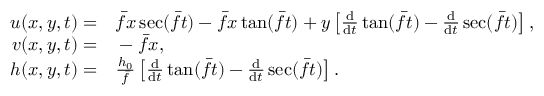Convert formula to latex. <formula><loc_0><loc_0><loc_500><loc_500>\begin{array} { r l } { u ( x , y , t ) = } & \bar { f } x \sec ( \bar { f } t ) - \bar { f } x \tan ( \bar { f } t ) + y \left [ \frac { d } { d t } \tan ( \bar { f } t ) - \frac { d } { d t } \sec ( \bar { f } t ) \right ] , } \\ { v ( x , y , t ) = } & - \bar { f } x , } \\ { h ( x , y , t ) = } & \frac { h _ { 0 } } { \bar { f } } \left [ \frac { d } { d t } \tan ( \bar { f } t ) - \frac { d } { d t } \sec ( \bar { f } t ) \right ] . } \end{array}</formula> 